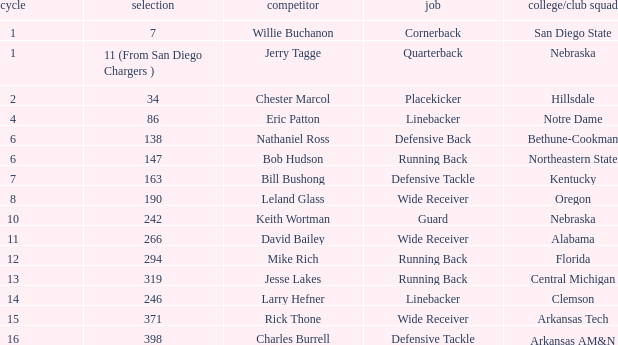Which option features a school or club team from kentucky? 163.0. 